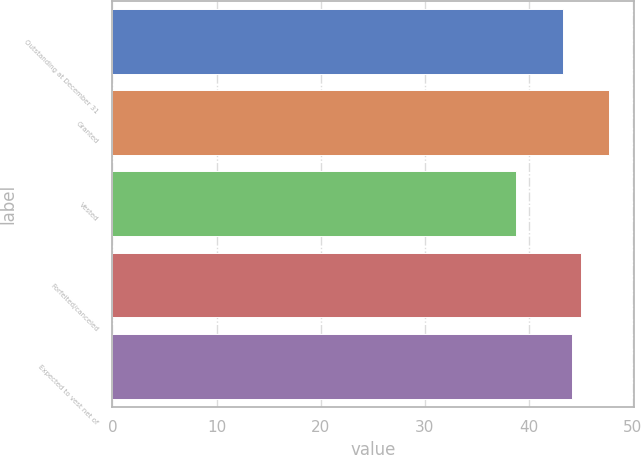Convert chart to OTSL. <chart><loc_0><loc_0><loc_500><loc_500><bar_chart><fcel>Outstanding at December 31<fcel>Granted<fcel>Vested<fcel>Forfeited/canceled<fcel>Expected to vest net of<nl><fcel>43.27<fcel>47.71<fcel>38.78<fcel>45.05<fcel>44.16<nl></chart> 